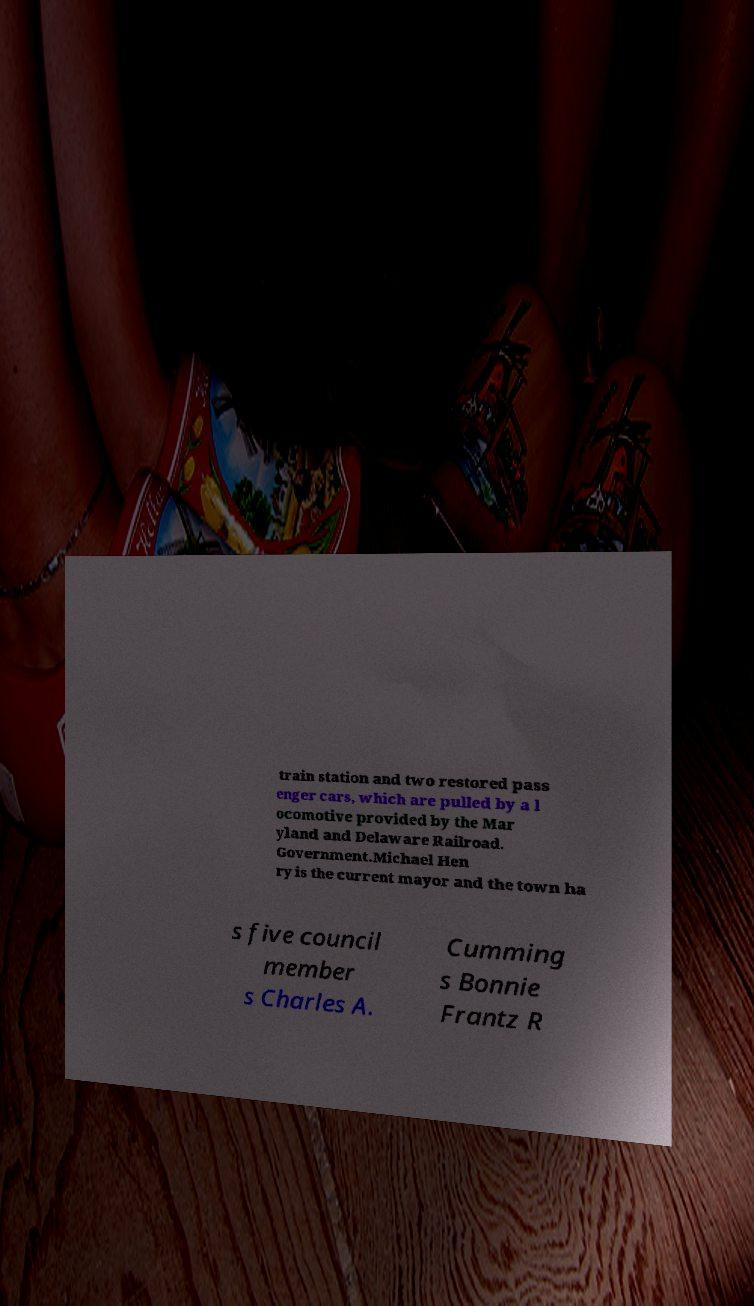Please read and relay the text visible in this image. What does it say? train station and two restored pass enger cars, which are pulled by a l ocomotive provided by the Mar yland and Delaware Railroad. Government.Michael Hen ry is the current mayor and the town ha s five council member s Charles A. Cumming s Bonnie Frantz R 